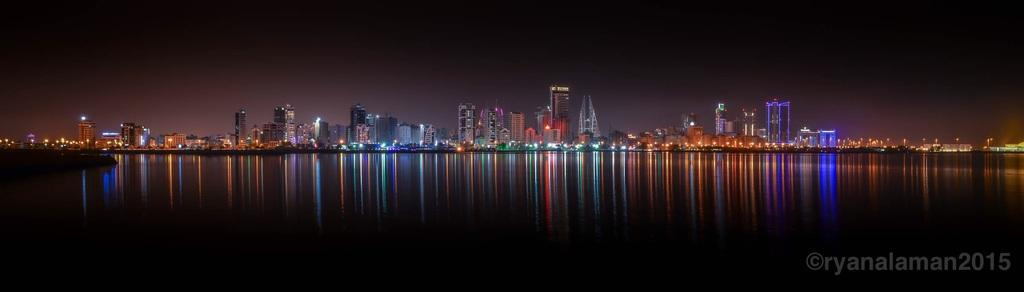What can be seen in the background of the image? There are buildings and lights visible in the background of the image. What is written at the bottom right of the image? There is some text written at the bottom right of the image. Are there any numbers associated with the text in the image? Yes, there are numbers associated with the text in the image. Can you see a comb with cherries in the image? There is no comb or cherries present in the image. Is there a nail sticking out of the text in the image? There is no nail present in the image. 